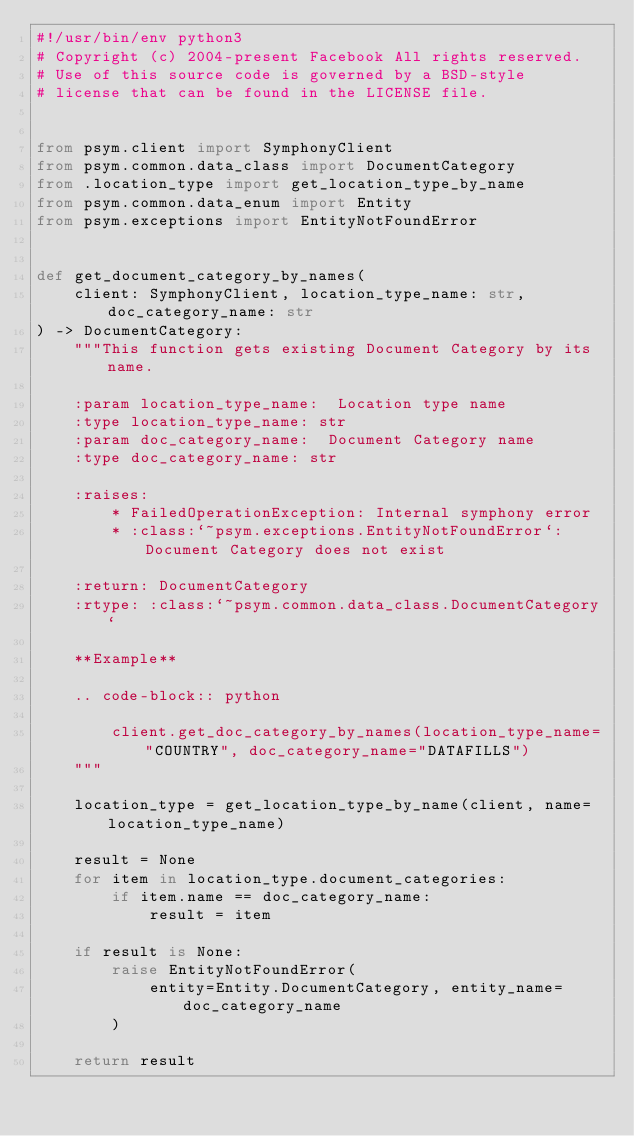Convert code to text. <code><loc_0><loc_0><loc_500><loc_500><_Python_>#!/usr/bin/env python3
# Copyright (c) 2004-present Facebook All rights reserved.
# Use of this source code is governed by a BSD-style
# license that can be found in the LICENSE file.


from psym.client import SymphonyClient
from psym.common.data_class import DocumentCategory
from .location_type import get_location_type_by_name
from psym.common.data_enum import Entity
from psym.exceptions import EntityNotFoundError


def get_document_category_by_names(
    client: SymphonyClient, location_type_name: str, doc_category_name: str
) -> DocumentCategory:
    """This function gets existing Document Category by its name.

    :param location_type_name:  Location type name
    :type location_type_name: str
    :param doc_category_name:  Document Category name
    :type doc_category_name: str

    :raises:
        * FailedOperationException: Internal symphony error
        * :class:`~psym.exceptions.EntityNotFoundError`: Document Category does not exist

    :return: DocumentCategory
    :rtype: :class:`~psym.common.data_class.DocumentCategory`

    **Example**

    .. code-block:: python

        client.get_doc_category_by_names(location_type_name="COUNTRY", doc_category_name="DATAFILLS")
    """

    location_type = get_location_type_by_name(client, name=location_type_name)

    result = None
    for item in location_type.document_categories:
        if item.name == doc_category_name:
            result = item

    if result is None:
        raise EntityNotFoundError(
            entity=Entity.DocumentCategory, entity_name=doc_category_name
        )

    return result
</code> 